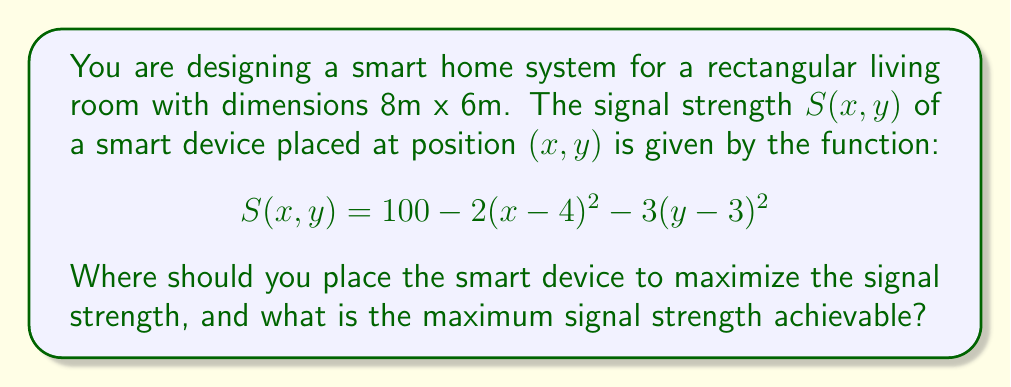Teach me how to tackle this problem. To find the optimal placement of the smart device and the maximum signal strength, we need to use multivariable calculus to find the maximum of the function $S(x,y)$.

Step 1: Find the partial derivatives of $S(x,y)$ with respect to $x$ and $y$.

$$\frac{\partial S}{\partial x} = -4(x-4)$$
$$\frac{\partial S}{\partial y} = -6(y-3)$$

Step 2: Set both partial derivatives to zero to find the critical point.

$$-4(x-4) = 0 \implies x = 4$$
$$-6(y-3) = 0 \implies y = 3$$

Step 3: Verify that this critical point is a maximum by checking the second partial derivatives.

$$\frac{\partial^2 S}{\partial x^2} = -4$$
$$\frac{\partial^2 S}{\partial y^2} = -6$$
$$\frac{\partial^2 S}{\partial x \partial y} = \frac{\partial^2 S}{\partial y \partial x} = 0$$

The Hessian matrix is:
$$H = \begin{bmatrix} -4 & 0 \\ 0 & -6 \end{bmatrix}$$

Since both second partial derivatives are negative and the determinant of the Hessian is positive (24 > 0), this critical point is a maximum.

Step 4: Calculate the maximum signal strength by plugging the optimal coordinates into the original function.

$$S(4,3) = 100 - 2(4-4)^2 - 3(3-3)^2 = 100$$

Therefore, the smart device should be placed at the point (4m, 3m) in the living room, which is exactly at the center of the room. The maximum signal strength achievable is 100.
Answer: Place the device at (4m, 3m); Maximum signal strength: 100 